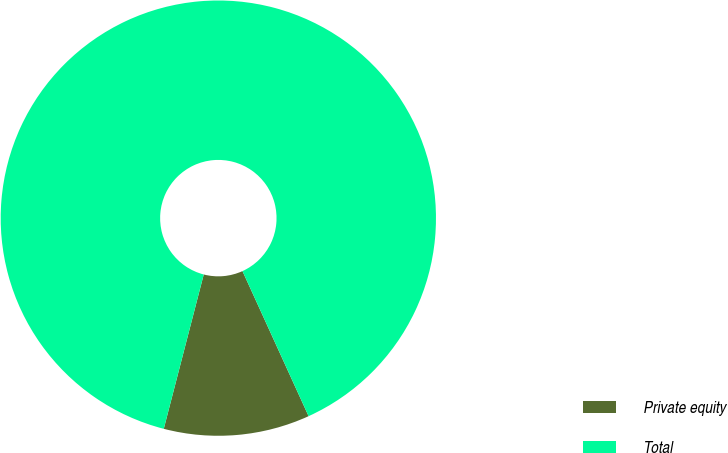<chart> <loc_0><loc_0><loc_500><loc_500><pie_chart><fcel>Private equity<fcel>Total<nl><fcel>10.84%<fcel>89.16%<nl></chart> 